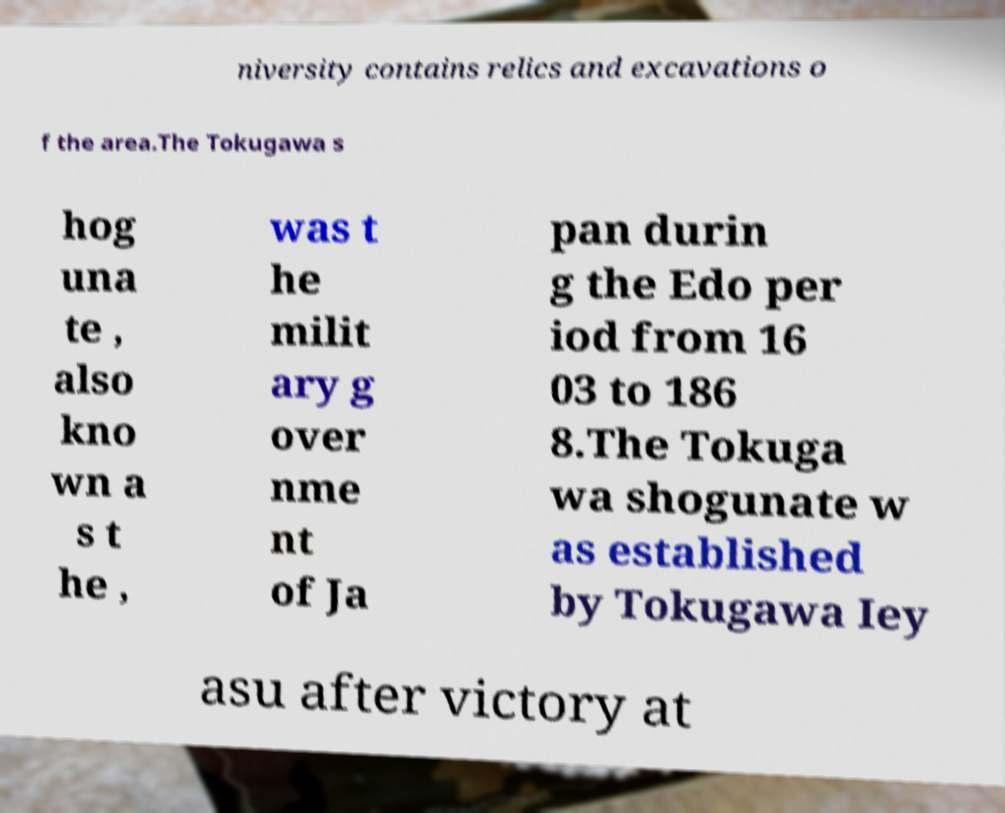Can you read and provide the text displayed in the image?This photo seems to have some interesting text. Can you extract and type it out for me? niversity contains relics and excavations o f the area.The Tokugawa s hog una te , also kno wn a s t he , was t he milit ary g over nme nt of Ja pan durin g the Edo per iod from 16 03 to 186 8.The Tokuga wa shogunate w as established by Tokugawa Iey asu after victory at 